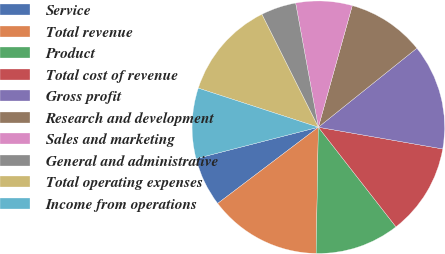Convert chart to OTSL. <chart><loc_0><loc_0><loc_500><loc_500><pie_chart><fcel>Service<fcel>Total revenue<fcel>Product<fcel>Total cost of revenue<fcel>Gross profit<fcel>Research and development<fcel>Sales and marketing<fcel>General and administrative<fcel>Total operating expenses<fcel>Income from operations<nl><fcel>6.31%<fcel>14.41%<fcel>10.81%<fcel>11.71%<fcel>13.51%<fcel>9.91%<fcel>7.21%<fcel>4.5%<fcel>12.61%<fcel>9.01%<nl></chart> 